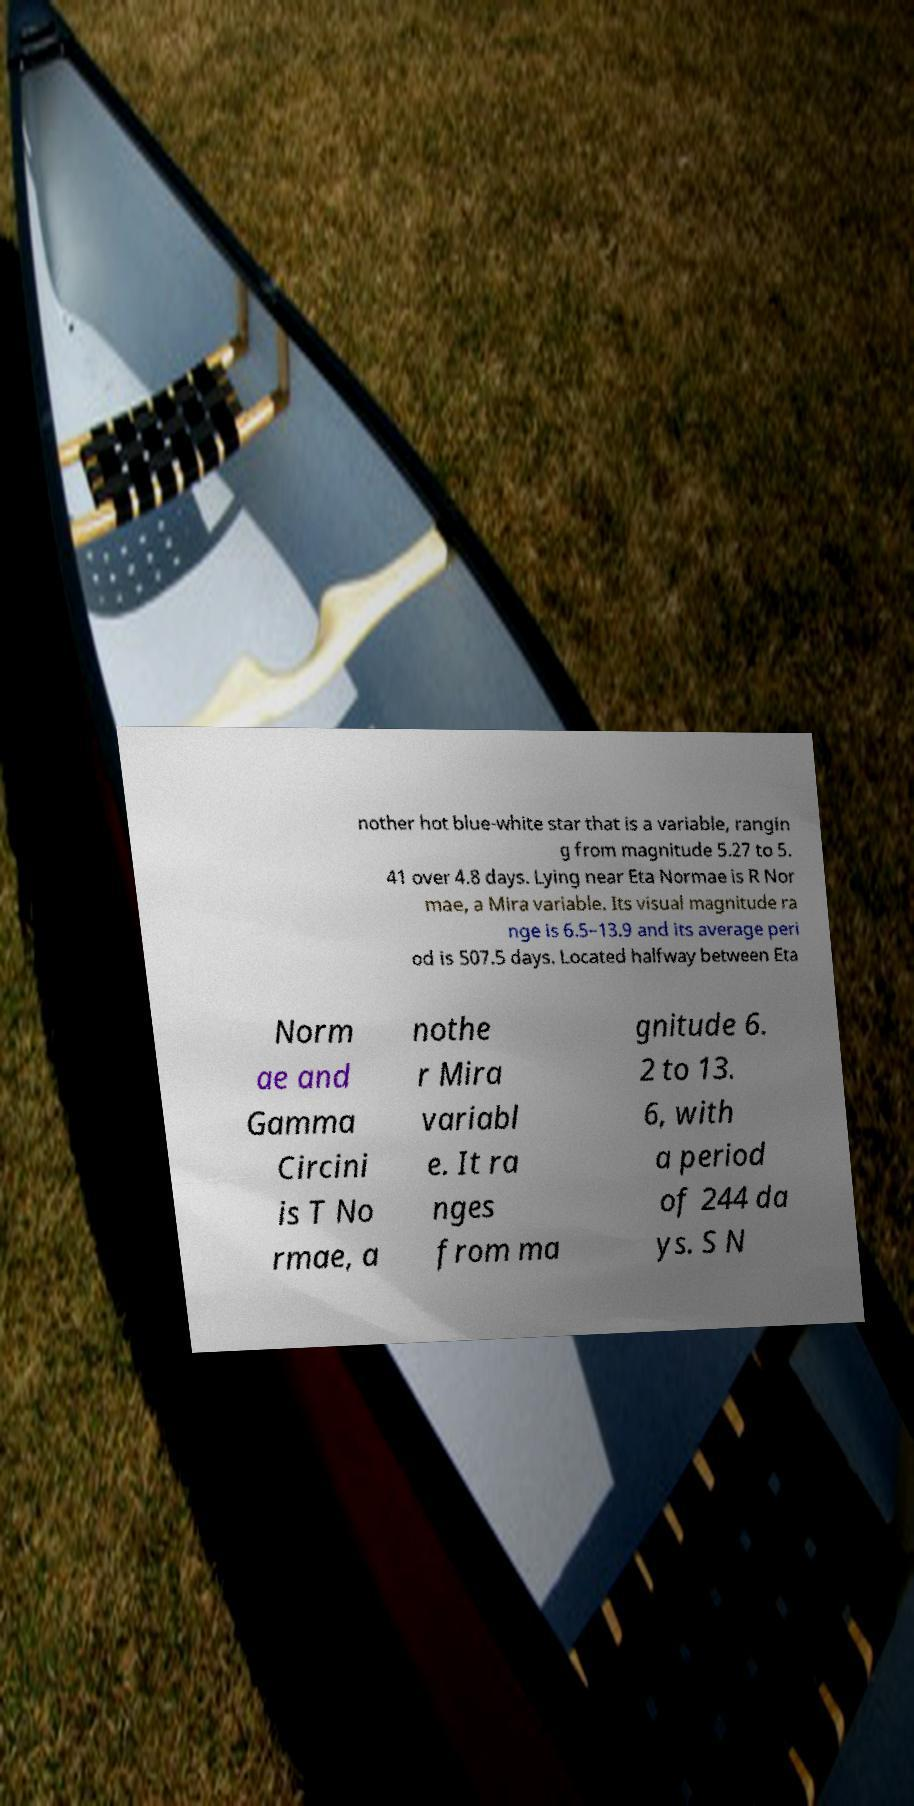Can you read and provide the text displayed in the image?This photo seems to have some interesting text. Can you extract and type it out for me? nother hot blue-white star that is a variable, rangin g from magnitude 5.27 to 5. 41 over 4.8 days. Lying near Eta Normae is R Nor mae, a Mira variable. Its visual magnitude ra nge is 6.5–13.9 and its average peri od is 507.5 days. Located halfway between Eta Norm ae and Gamma Circini is T No rmae, a nothe r Mira variabl e. It ra nges from ma gnitude 6. 2 to 13. 6, with a period of 244 da ys. S N 